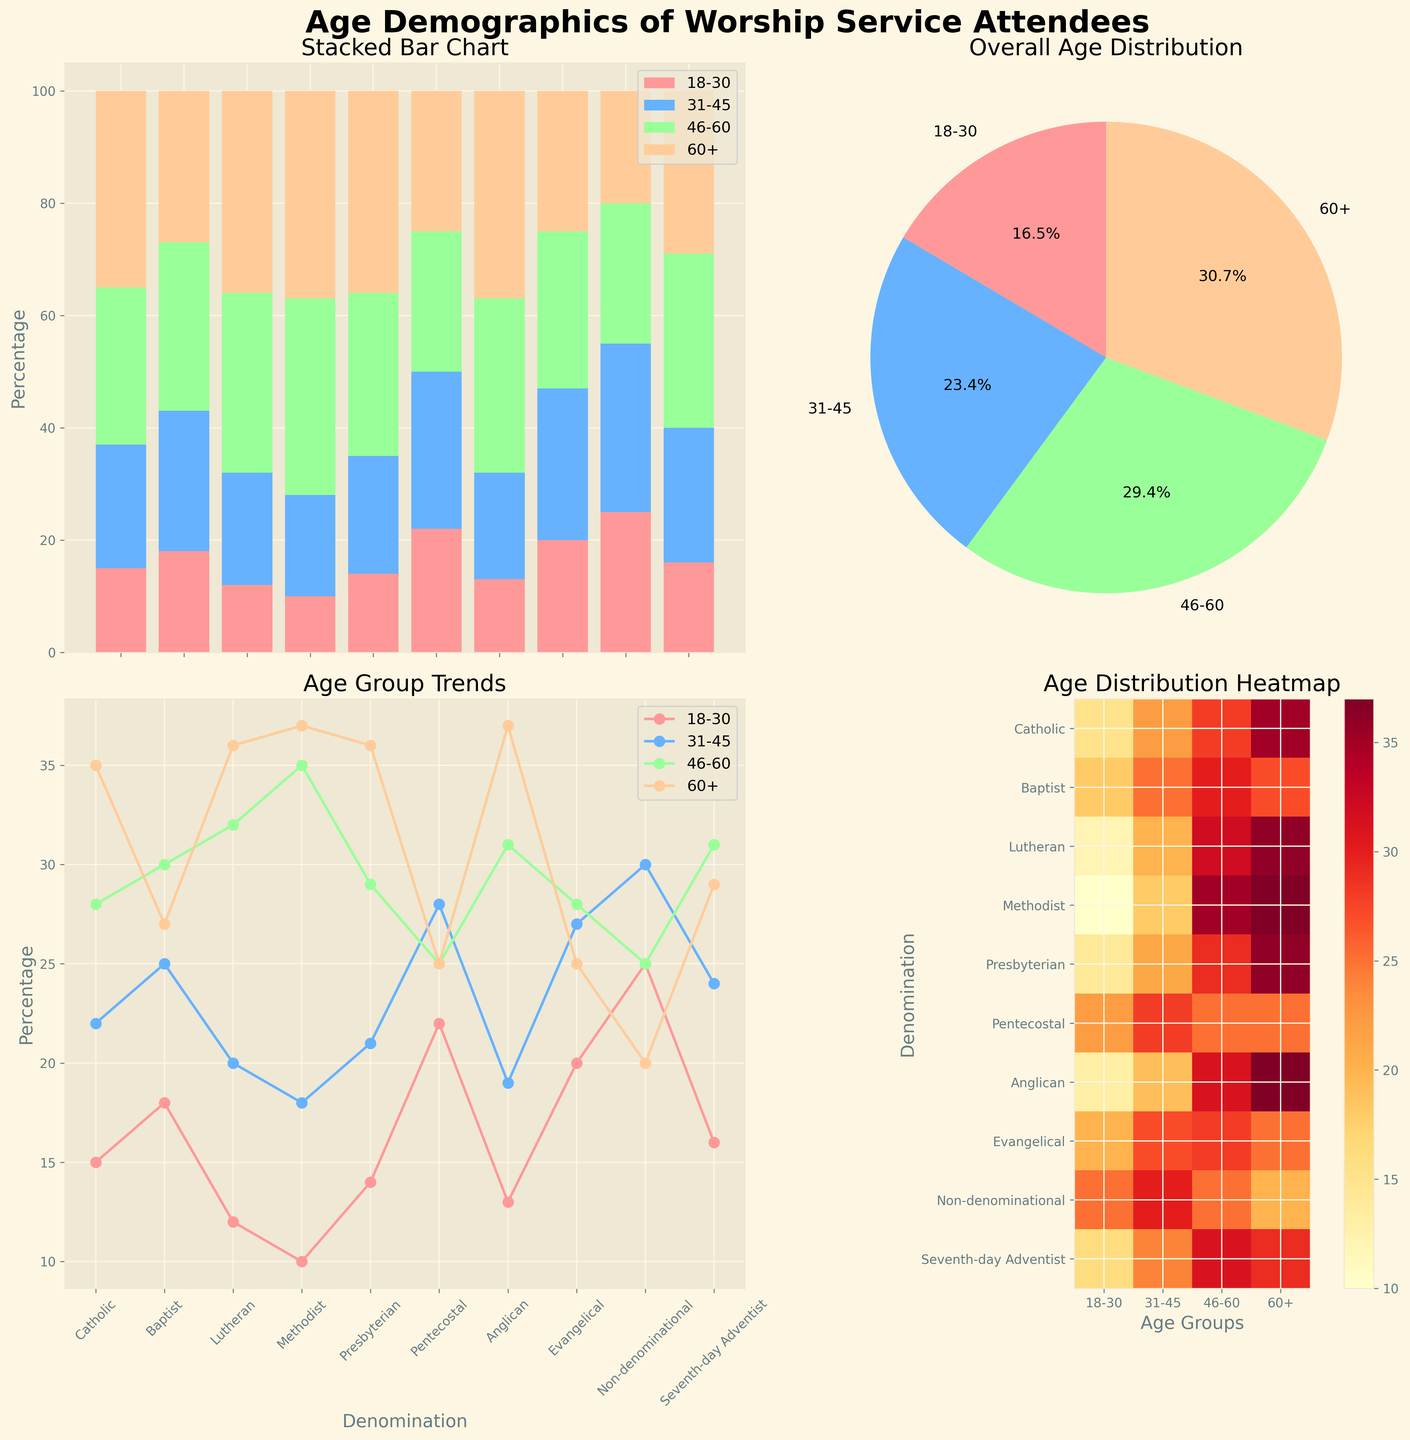What's the title of the figure? The title is located at the top center of the figure, with the text in a bold font.
Answer: Age Demographics of Worship Service Attendees What does the pie chart represent? The pie chart is located in the top right corner and shows the overall percentage distribution of each age group across all denominations.
Answer: Overall age distribution How many denominations have attendees aged 18-30 represented in the stacked bar chart? By looking at the leftmost subplot (the stacked bar chart), you can count the bars that have the color representing the 18-30 age group. All bars contain this color.
Answer: 10 Which age group has the highest percentage in the pie chart? The pie chart provides percentage labels for each slice; by comparing these percentages, the largest value represents the age group with the highest percentage.
Answer: 60+ For the denomination 'Pentecostal,' which age group has the smallest percentage in the line chart? In the line chart, locate the data points for 'Pentecostal' across all age groups and identify the lowest value.
Answer: 46-60 and 60+ (both 25%) Which age group shows the largest variation across denominations in the line chart? The line chart shows different lines for each age group. By observing the range and amplitude of each line, the age group with the largest peaks and valleys will have the largest variation.
Answer: 18-30 In the heatmap, which denomination has a higher percentage for the age group 60+, 'Lutheran' or 'Methodist'? Look at the bottom right subplot and compare the color intensity for the age group 60+ between the respective rows for 'Lutheran' and 'Methodist.'
Answer: Methodist Which denomination has the fewest attendees in the 31-45 age group according to the bar chart? Refer to the stacked bar chart and look for the smallest segment of color representing the 31-45 age group.
Answer: Methodist What's the sum of percentages for the age group 18-30 in 'Methodist' and 'Baptist' denominations in the stacked bar chart? In the stacked bar chart, identify the segment for 18-30 for both denominations and add the numbers (10 + 18 = 28).
Answer: 28 Comparing the aggregate percentages of the age group 46-60, which has a higher value: 'Catholic' or 'Seventh-day Adventist'? Use the stacked bar chart to compare the segments representing 46-60 between the two denominations (Catholic: 28, Adventist: 31).
Answer: Seventh-day Adventist 